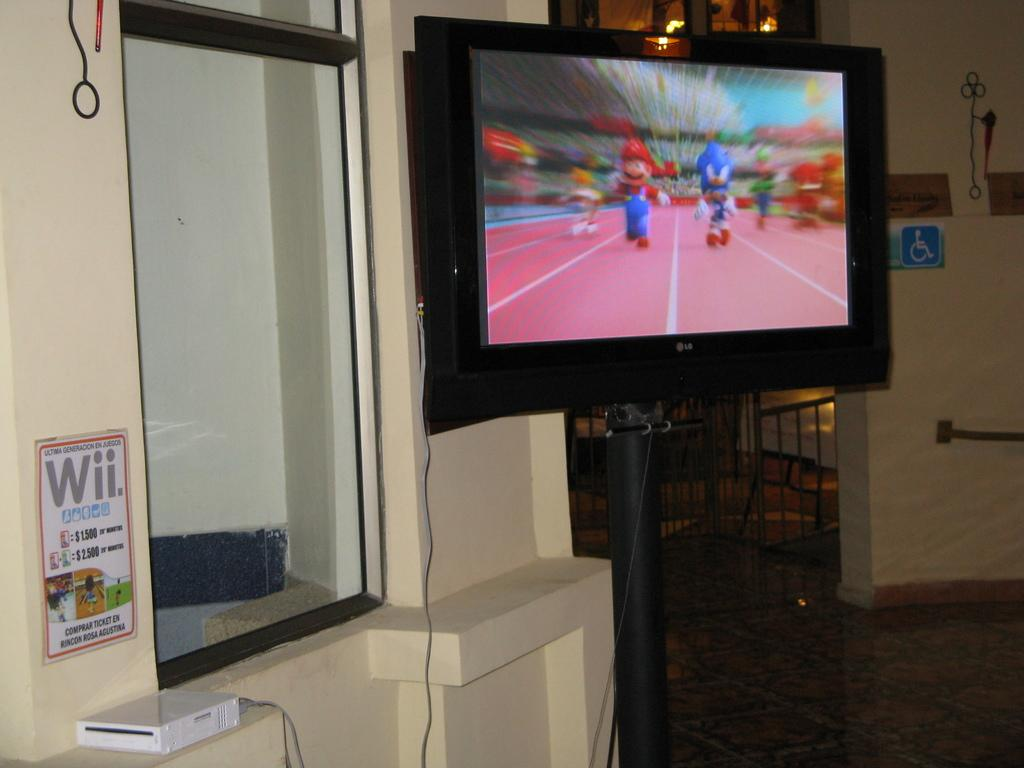<image>
Write a terse but informative summary of the picture. An LG branded television is showing Mario and Sonic at the olympics being played on a nintendo WII. 